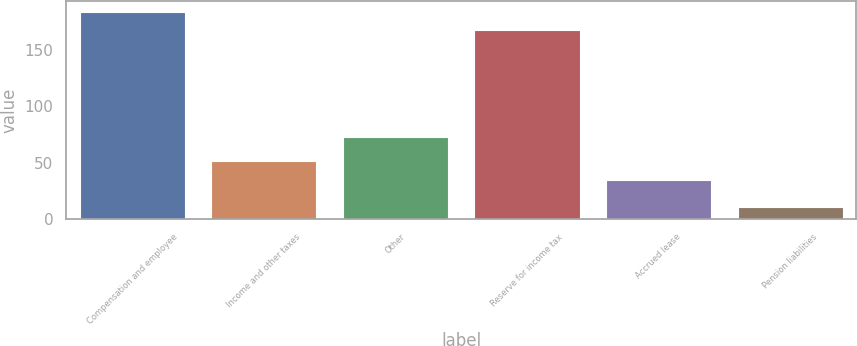Convert chart to OTSL. <chart><loc_0><loc_0><loc_500><loc_500><bar_chart><fcel>Compensation and employee<fcel>Income and other taxes<fcel>Other<fcel>Reserve for income tax<fcel>Accrued lease<fcel>Pension liabilities<nl><fcel>184.12<fcel>51.32<fcel>72.8<fcel>167.6<fcel>34.8<fcel>11.2<nl></chart> 